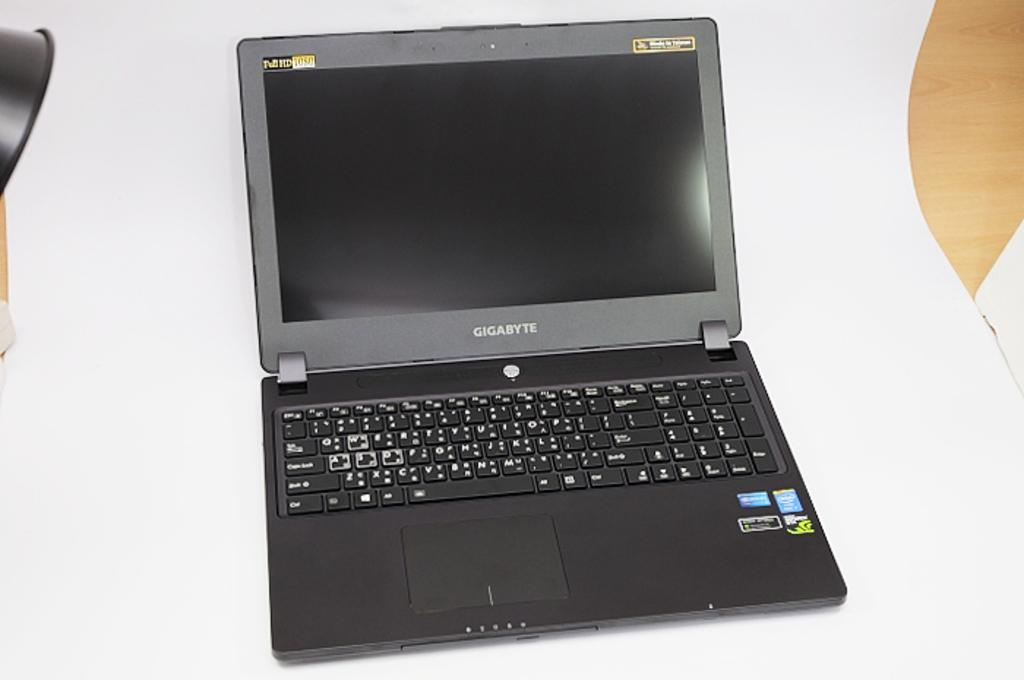<image>
Create a compact narrative representing the image presented. a grey lap top computer with the words Gigabyte on it 